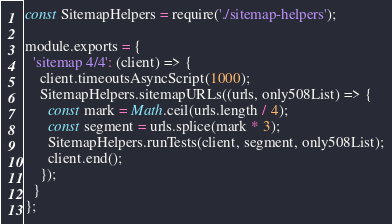Convert code to text. <code><loc_0><loc_0><loc_500><loc_500><_JavaScript_>const SitemapHelpers = require('./sitemap-helpers');

module.exports = {
  'sitemap 4/4': (client) => {
    client.timeoutsAsyncScript(1000);
    SitemapHelpers.sitemapURLs((urls, only508List) => {
      const mark = Math.ceil(urls.length / 4);
      const segment = urls.splice(mark * 3);
      SitemapHelpers.runTests(client, segment, only508List);
      client.end();
    });
  }
};
</code> 